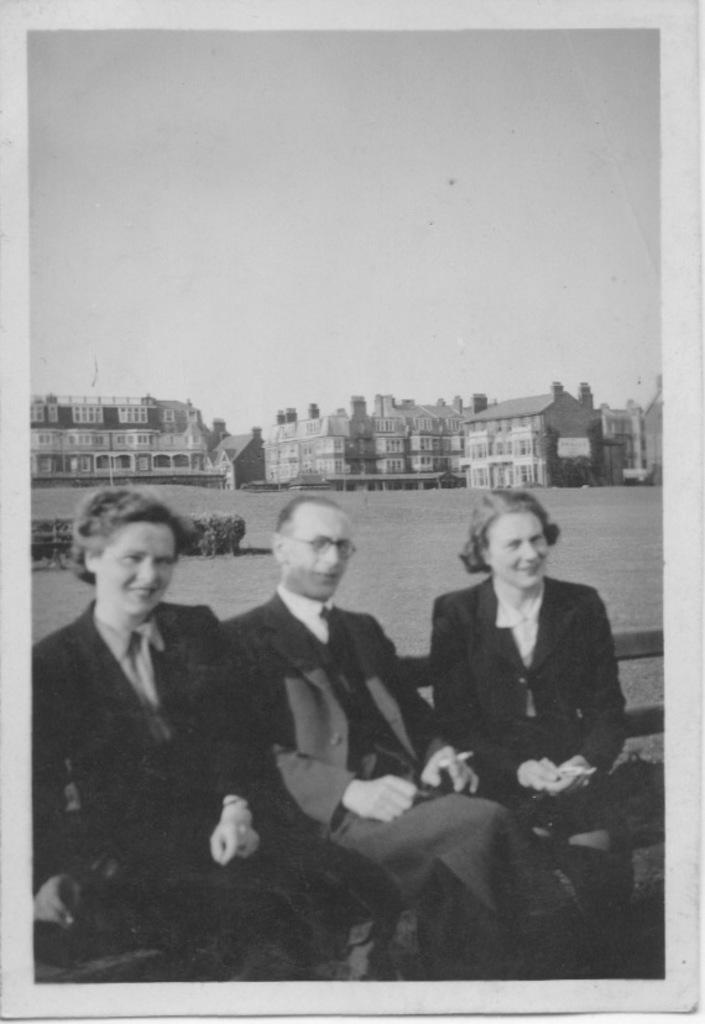What is the color scheme of the image? The image is black and white. What can be seen in the background of the image? There are buildings in the background of the image. What are the people in the image doing? The people in the image are sitting. What is the facial expression of the people in the image? The people in the image are smiling. Can you hear the whistle of the yak in the image? There is no yak or whistling sound present in the image, as it is a black and white image featuring people sitting and smiling. 